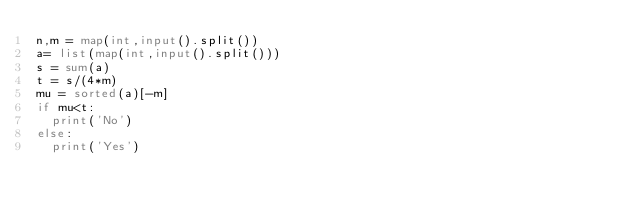<code> <loc_0><loc_0><loc_500><loc_500><_Python_>n,m = map(int,input().split())
a= list(map(int,input().split()))
s = sum(a)
t = s/(4*m)
mu = sorted(a)[-m]
if mu<t:
  print('No')
else:
  print('Yes')</code> 